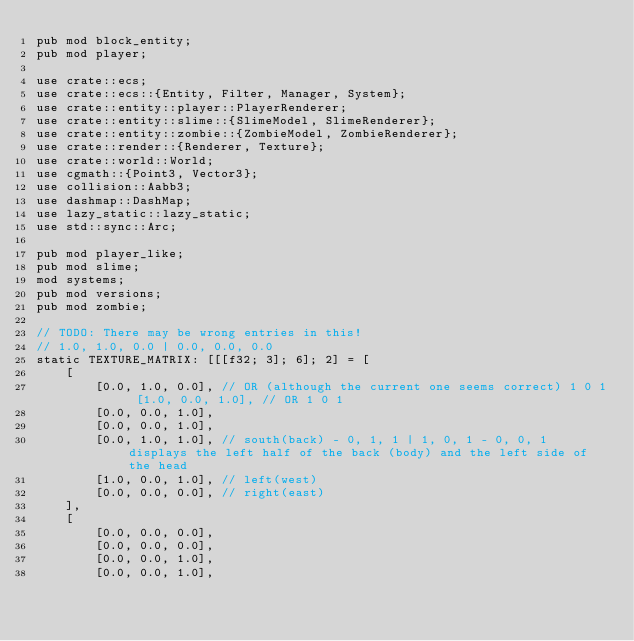Convert code to text. <code><loc_0><loc_0><loc_500><loc_500><_Rust_>pub mod block_entity;
pub mod player;

use crate::ecs;
use crate::ecs::{Entity, Filter, Manager, System};
use crate::entity::player::PlayerRenderer;
use crate::entity::slime::{SlimeModel, SlimeRenderer};
use crate::entity::zombie::{ZombieModel, ZombieRenderer};
use crate::render::{Renderer, Texture};
use crate::world::World;
use cgmath::{Point3, Vector3};
use collision::Aabb3;
use dashmap::DashMap;
use lazy_static::lazy_static;
use std::sync::Arc;

pub mod player_like;
pub mod slime;
mod systems;
pub mod versions;
pub mod zombie;

// TODO: There may be wrong entries in this!
// 1.0, 1.0, 0.0 | 0.0, 0.0, 0.0
static TEXTURE_MATRIX: [[[f32; 3]; 6]; 2] = [
    [
        [0.0, 1.0, 0.0], // OR (although the current one seems correct) 1 0 1 [1.0, 0.0, 1.0], // OR 1 0 1
        [0.0, 0.0, 1.0],
        [0.0, 0.0, 1.0],
        [0.0, 1.0, 1.0], // south(back) - 0, 1, 1 | 1, 0, 1 - 0, 0, 1 displays the left half of the back (body) and the left side of the head
        [1.0, 0.0, 1.0], // left(west)
        [0.0, 0.0, 0.0], // right(east)
    ],
    [
        [0.0, 0.0, 0.0],
        [0.0, 0.0, 0.0],
        [0.0, 0.0, 1.0],
        [0.0, 0.0, 1.0],</code> 